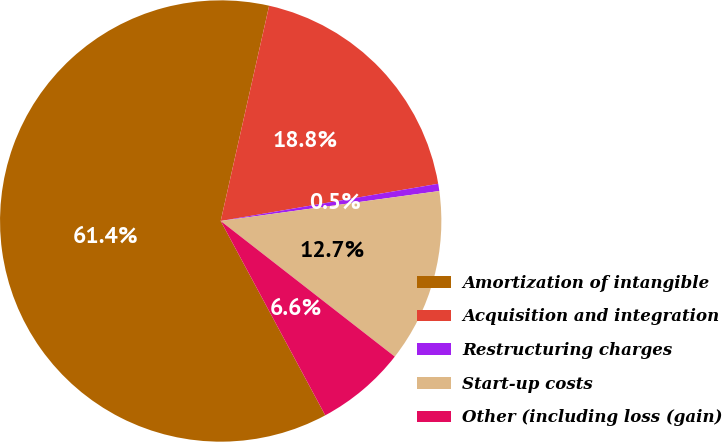<chart> <loc_0><loc_0><loc_500><loc_500><pie_chart><fcel>Amortization of intangible<fcel>Acquisition and integration<fcel>Restructuring charges<fcel>Start-up costs<fcel>Other (including loss (gain)<nl><fcel>61.38%<fcel>18.78%<fcel>0.53%<fcel>12.7%<fcel>6.61%<nl></chart> 